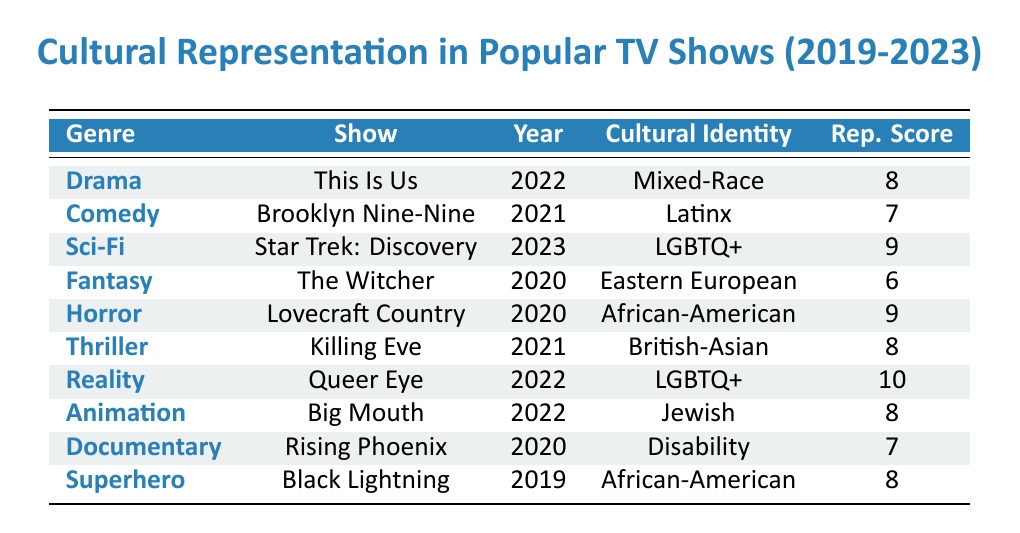What is the representation score of "This Is Us"? By looking at the table, I find the row for "This Is Us" under the Drama genre, which shows a representation score of 8.
Answer: 8 Which genre has the highest representation score? The highest representation score in the table is 10, which belongs to the Reality genre (Queer Eye).
Answer: Reality How many shows represent Asian cultural identities? The table lists only one show that represents an Asian cultural identity, which is "Killing Eve" (British-Asian).
Answer: 1 What is the average representation score for shows in the Horror genre? There is only one Horror show in the table, "Lovecraft Country," with a representation score of 9. Since there’s only one score, the average is also 9.
Answer: 9 Did any show released in 2023 have a representation score of 8 or lower? "Star Trek: Discovery" is the only show from 2023, which has a representation score of 9, so there are no shows from that year with a score of 8 or lower.
Answer: No Which show has the lowest representation score and what is its cultural identity? The show with the lowest score is "The Witcher," which has a representation score of 6, and it represents Eastern European cultural identity.
Answer: The Witcher, Eastern European What percentage of the shows in the table have a representation score of 8 or higher? There are 10 shows total, with 6 of them (This Is Us, Star Trek: Discovery, Lovecraft Country, Queer Eye, Big Mouth, and Black Lightning) having scores of 8 or higher. Calculating the percentage: (6/10) * 100 = 60%.
Answer: 60% Is there any show from the Superhero genre in the table? Yes, the table includes the show "Black Lightning," which is categorized under the Superhero genre.
Answer: Yes What cultural identity is represented in the show "Brooklyn Nine-Nine" and what is its representation score? "Brooklyn Nine-Nine" has a cultural identity of Latinx and a representation score of 7, as shown in the table.
Answer: Latinx, 7 